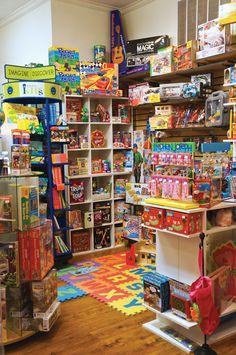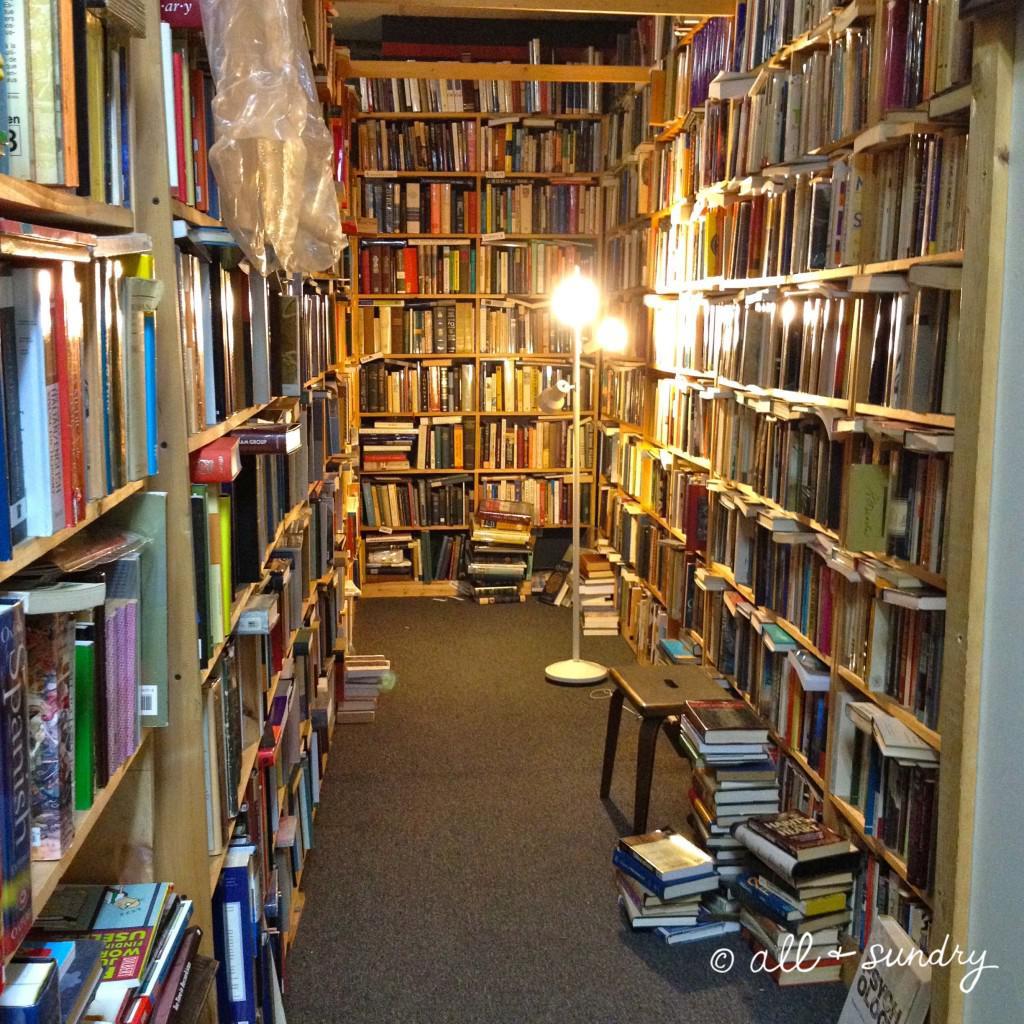The first image is the image on the left, the second image is the image on the right. For the images displayed, is the sentence "The right image includes a person standing behind a counter that has three white squares in a row on it, and the wall near the counter is filled almost to the ceiling with books." factually correct? Answer yes or no. No. The first image is the image on the left, the second image is the image on the right. Examine the images to the left and right. Is the description "There are two people in dark shirts behind the counter of a bookstore," accurate? Answer yes or no. No. 